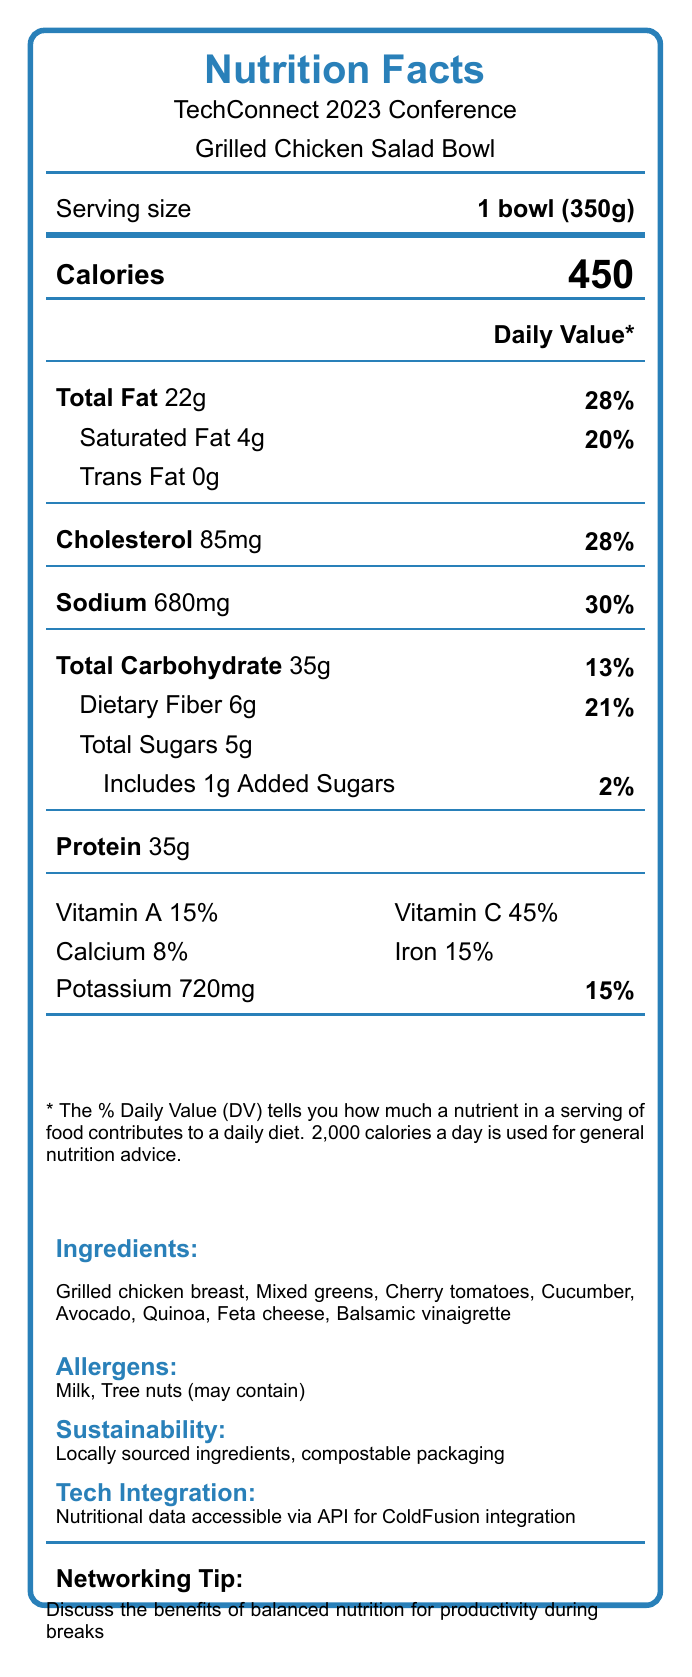what is the serving size of the Grilled Chicken Salad Bowl? The serving size information is located near the top of the document under the "Serving size" label.
Answer: 1 bowl (350g) how many calories are in one serving of the Grilled Chicken Salad Bowl? The number of calories per serving is displayed prominently in the middle of the document under the "Calories" label.
Answer: 450 What percentage of the daily value for total fat does one serving of the Grilled Chicken Salad Bowl provide? This information is provided in the "Daily Value*" section next to "Total Fat."
Answer: 28% What are the ingredients listed for the Grilled Chicken Salad Bowl? The ingredients section near the bottom of the document lists all the ingredients.
Answer: Grilled chicken breast, Mixed greens, Cherry tomatoes, Cucumber, Avocado, Quinoa, Feta cheese, Balsamic vinaigrette Are there any allergens present in the Grilled Chicken Salad Bowl? The allergens section indicates that the salad contains Milk and may contain Tree nuts.
Answer: Yes What is the sodium content in one serving of the Grilled Chicken Salad Bowl? The sodium content is listed in the "Daily Value*" section under the "Sodium" label.
Answer: 680mg What is the protein content of one serving of the Grilled Chicken Salad Bowl? This information is displayed near the bottom of the "Daily Value*" section next to "Protein."
Answer: 35g What is the percentage of daily value for Vitamin C provided by the Grilled Chicken Salad Bowl? This information is provided in the vitamins and minerals section with the label "Vitamin C".
Answer: 45% Which nutrient has the highest daily value percentage in the Grilled Chicken Salad Bowl? 
  a. Total Fat 
  b. Sodium
  c. Vitamin C 
  d. Protein The daily value percentage for Vitamin C is the highest at 45%, as shown in the vitamins and minerals section.
Answer: c. Vitamin C What is the percent daily value of the dietary fiber content? 
  i. 10%
  ii. 15%
  iii. 21%
  iv. 30% The daily value percentage for dietary fiber is 21%, as indicated in the "Daily Value*" section under "Dietary Fiber."
Answer: iii. 21% Is there any trans fat present in the Grilled Chicken Salad Bowl? The "Trans Fat" entry in the "Daily Value*" section indicates 0g, confirming the absence of trans fat.
Answer: No Summarize the main idea of this document. This summary encapsulates the essential details found throughout the various sections of the nutritional facts label.
Answer: The document is a nutritional facts label for a Grilled Chicken Salad Bowl served at the TechConnect 2023 Conference. It provides detailed nutritional information, including caloric content, macronutrients, vitamins, and minerals. The ingredients, potential allergens, and sustainability information are also mentioned. The label offers a brief tip on how balanced nutrition can aid productivity during breaks and mentions that the nutritional data is accessible via API for ColdFusion integration. How is the nutritional data for the Grilled Chicken Salad Bowl accessed via tech integrations? The document mentions that the nutritional data is accessible via API for ColdFusion integration but does not provide specific details about how to access or use it.
Answer: Not enough information 